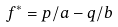Convert formula to latex. <formula><loc_0><loc_0><loc_500><loc_500>f ^ { * } = p / a - q / b</formula> 